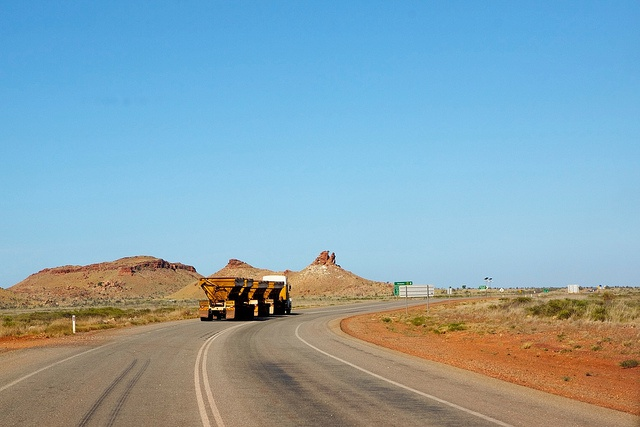Describe the objects in this image and their specific colors. I can see a truck in gray, black, brown, maroon, and orange tones in this image. 